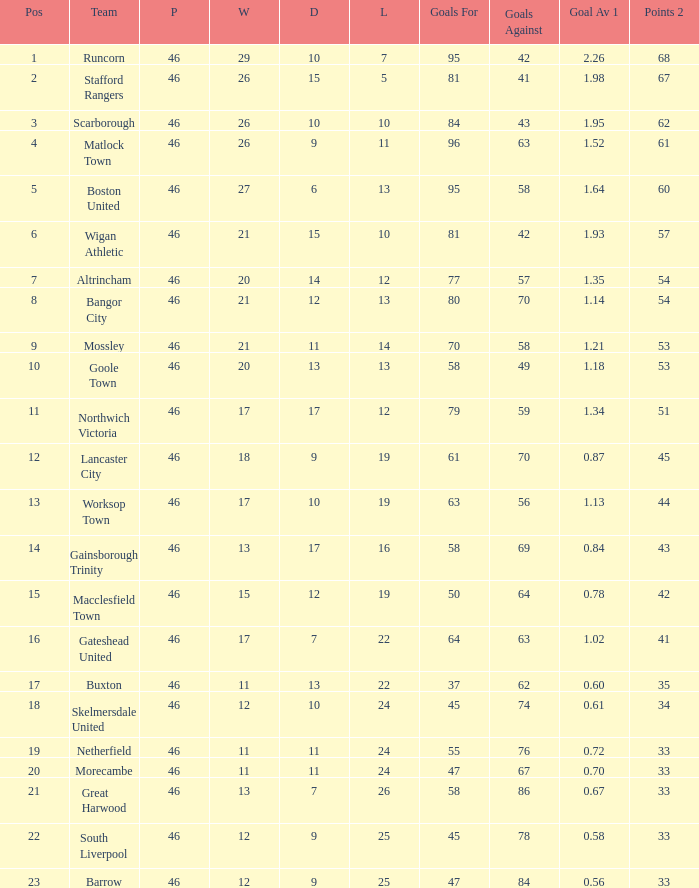Which team had goal ratios of Northwich Victoria. 